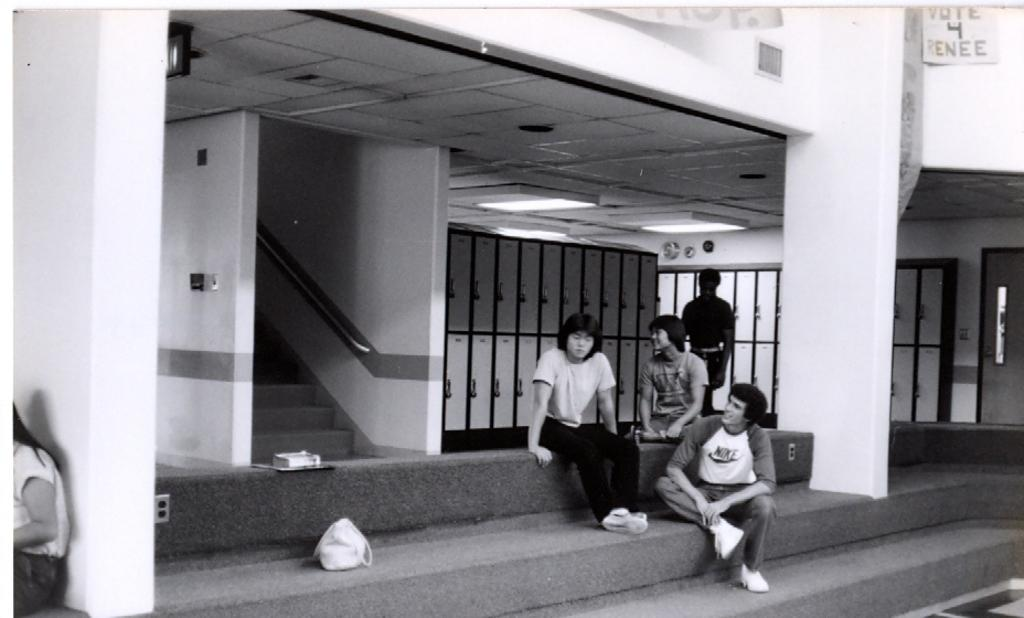How many people are in the image? There are people in the image, but the exact number is not specified. What are the people in the image doing? One person is standing, while others are sitting. What can be seen in the background of the image? In the background, there are stairs, a bag, lights, and lockers. What type of riddle is being solved by the people in the image? There is no indication in the image that the people are solving a riddle. How many eggs are visible in the image? There are no eggs present in the image. 